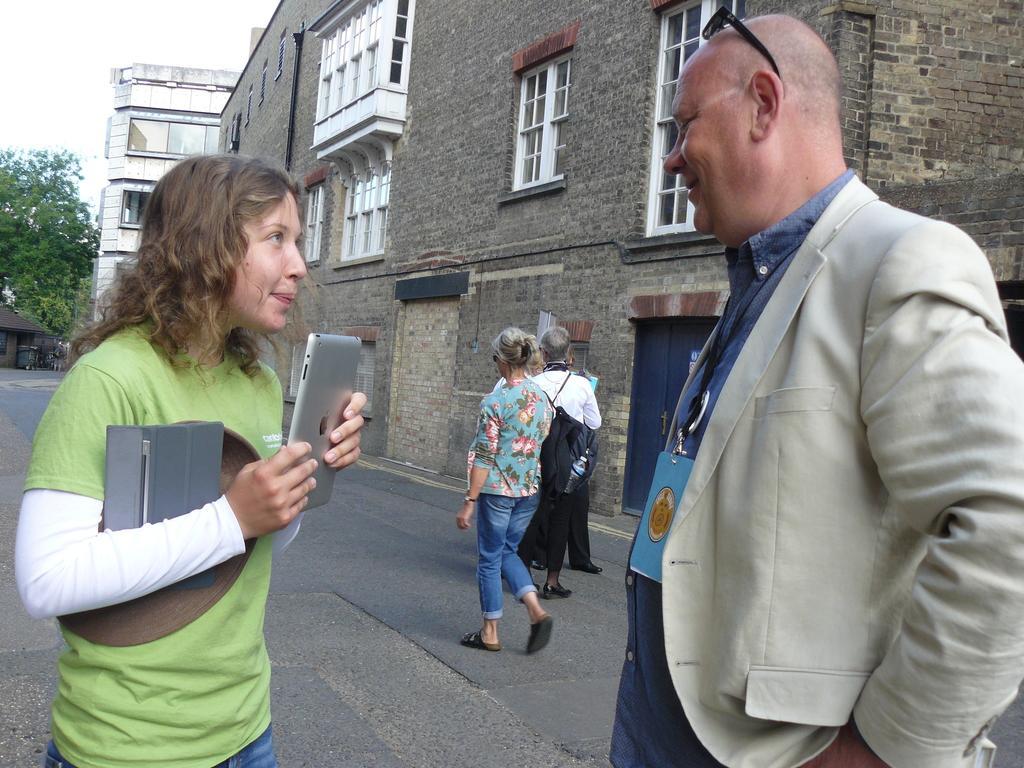In one or two sentences, can you explain what this image depicts? In this image we can see the people walking on the road and there are two persons standing on the road and the other person holding an object. In the background, we can see there are buildings, houses, trees and sky. 